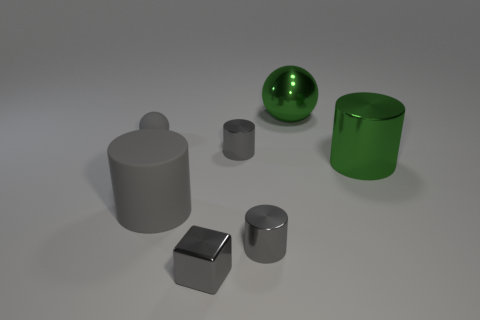There is a big thing that is the same material as the gray sphere; what is its shape?
Give a very brief answer. Cylinder. Are there any small matte objects to the right of the large green metallic thing behind the tiny rubber ball?
Give a very brief answer. No. What is the size of the green cylinder?
Your answer should be very brief. Large. How many objects are large gray matte things or small cyan matte cubes?
Your answer should be very brief. 1. Does the ball in front of the green ball have the same material as the cylinder on the left side of the tiny block?
Provide a short and direct response. Yes. There is a sphere that is the same material as the green cylinder; what color is it?
Your response must be concise. Green. What number of red matte balls have the same size as the green cylinder?
Ensure brevity in your answer.  0. How many other objects are the same color as the tiny shiny cube?
Offer a terse response. 4. There is a small thing on the left side of the large rubber cylinder; does it have the same shape as the green shiny object that is behind the small rubber sphere?
Give a very brief answer. Yes. There is a green metal object that is the same size as the green ball; what shape is it?
Make the answer very short. Cylinder. 